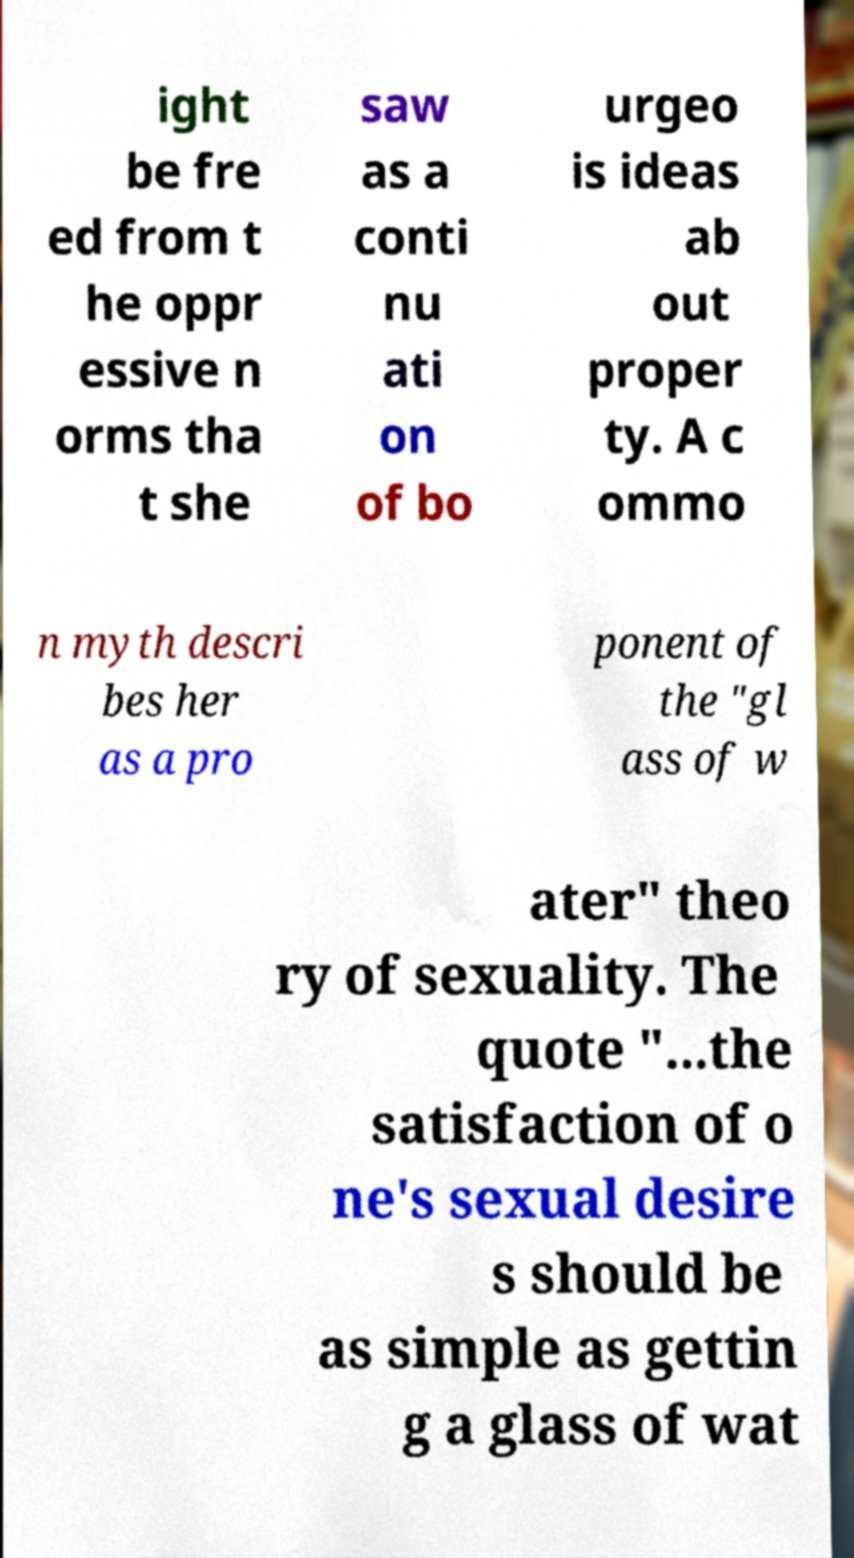I need the written content from this picture converted into text. Can you do that? ight be fre ed from t he oppr essive n orms tha t she saw as a conti nu ati on of bo urgeo is ideas ab out proper ty. A c ommo n myth descri bes her as a pro ponent of the "gl ass of w ater" theo ry of sexuality. The quote "...the satisfaction of o ne's sexual desire s should be as simple as gettin g a glass of wat 